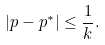Convert formula to latex. <formula><loc_0><loc_0><loc_500><loc_500>| p - p ^ { * } | \leq \frac { 1 } { k } .</formula> 